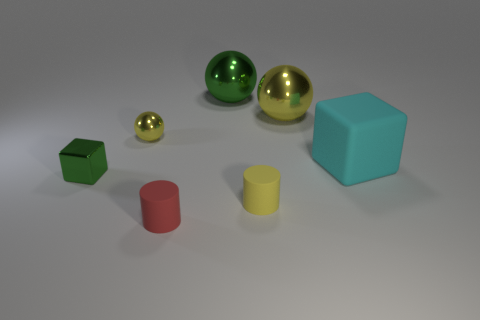There is a yellow object that is on the right side of the small yellow metallic thing and behind the metallic cube; what is its material?
Keep it short and to the point. Metal. How many small green things are the same shape as the big green thing?
Make the answer very short. 0. There is a green thing on the right side of the small shiny thing that is left of the yellow sphere in front of the large yellow shiny sphere; what is its size?
Provide a short and direct response. Large. Is the number of metallic objects behind the green block greater than the number of rubber cubes?
Your answer should be compact. Yes. Are there any big things?
Keep it short and to the point. Yes. What number of yellow shiny things are the same size as the yellow cylinder?
Make the answer very short. 1. Is the number of green things on the right side of the green cube greater than the number of tiny green metal cubes right of the red matte cylinder?
Your answer should be very brief. Yes. There is a ball that is the same size as the red matte cylinder; what is it made of?
Offer a terse response. Metal. The small yellow shiny thing is what shape?
Give a very brief answer. Sphere. What number of cyan objects are objects or metallic blocks?
Make the answer very short. 1. 